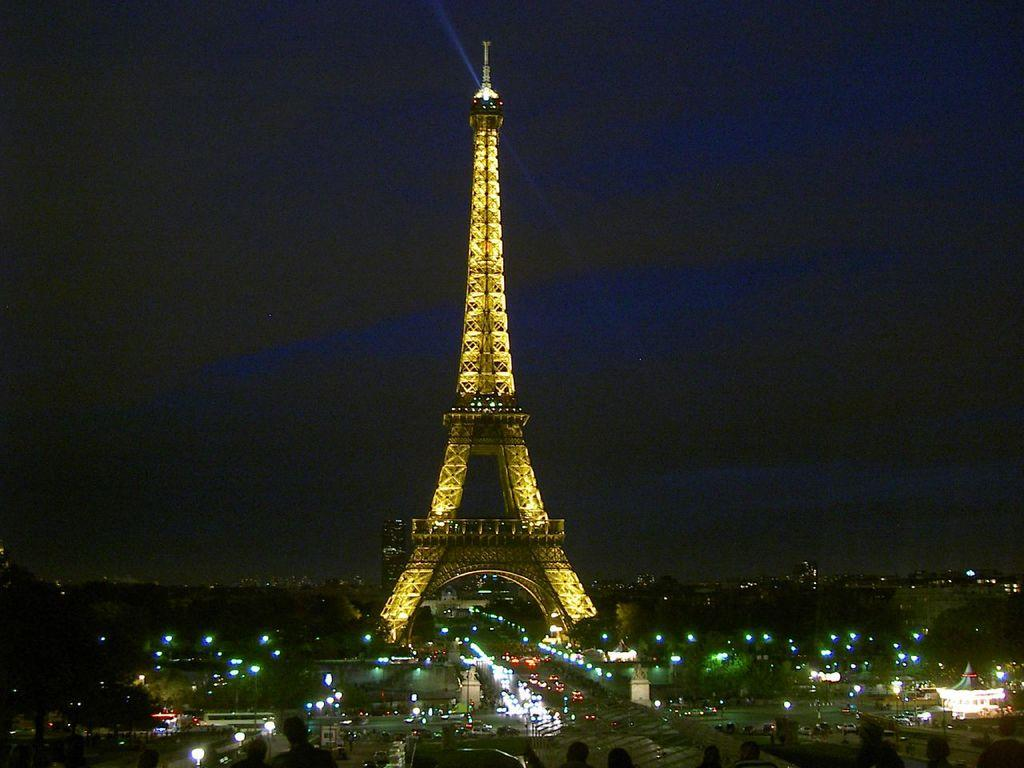What famous landmark can be seen in the image? The Eiffel Tower is visible in the image. What else is present in the image besides the Eiffel Tower? There are buildings, trees, lights, and vehicles visible in the image. Can you describe the buildings be seen in the image? Yes, there are buildings in the image. What type of vegetation is present in the image? Trees are present in the image. What can be seen illuminated in the image? Lights are visible in the image. What type of transportation is observable in the image? Vehicles are observable in the image. Where is the cactus located in the image? There is no cactus present in the image. What is the boy doing in the image? There is no boy present in the image. 